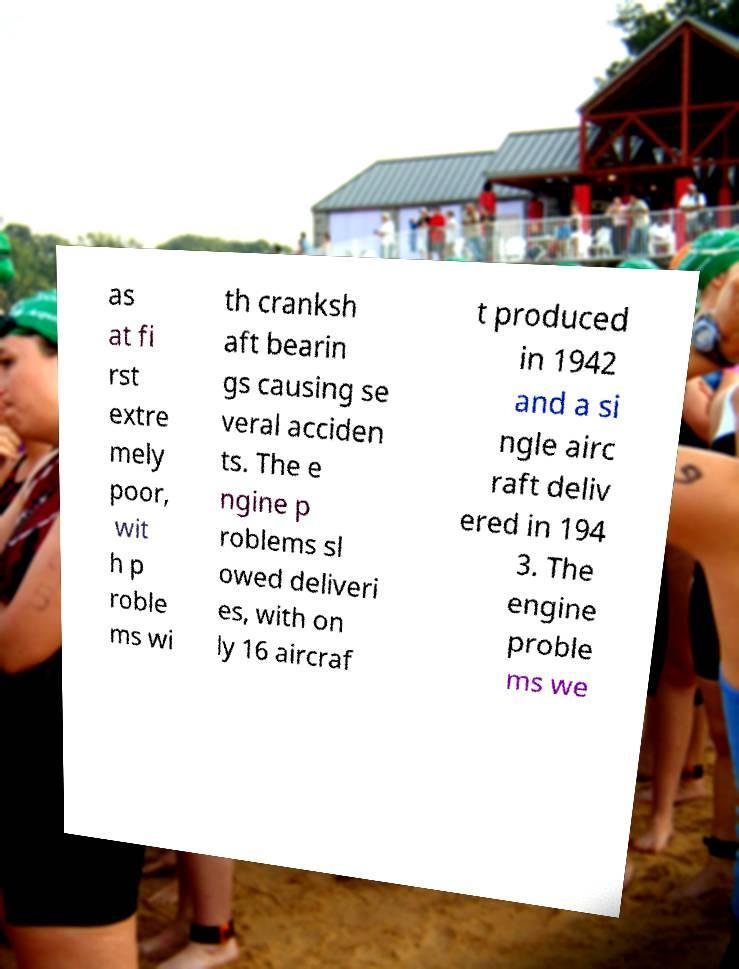Can you read and provide the text displayed in the image?This photo seems to have some interesting text. Can you extract and type it out for me? as at fi rst extre mely poor, wit h p roble ms wi th cranksh aft bearin gs causing se veral acciden ts. The e ngine p roblems sl owed deliveri es, with on ly 16 aircraf t produced in 1942 and a si ngle airc raft deliv ered in 194 3. The engine proble ms we 